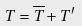Convert formula to latex. <formula><loc_0><loc_0><loc_500><loc_500>T = \overline { T } + T ^ { \prime }</formula> 